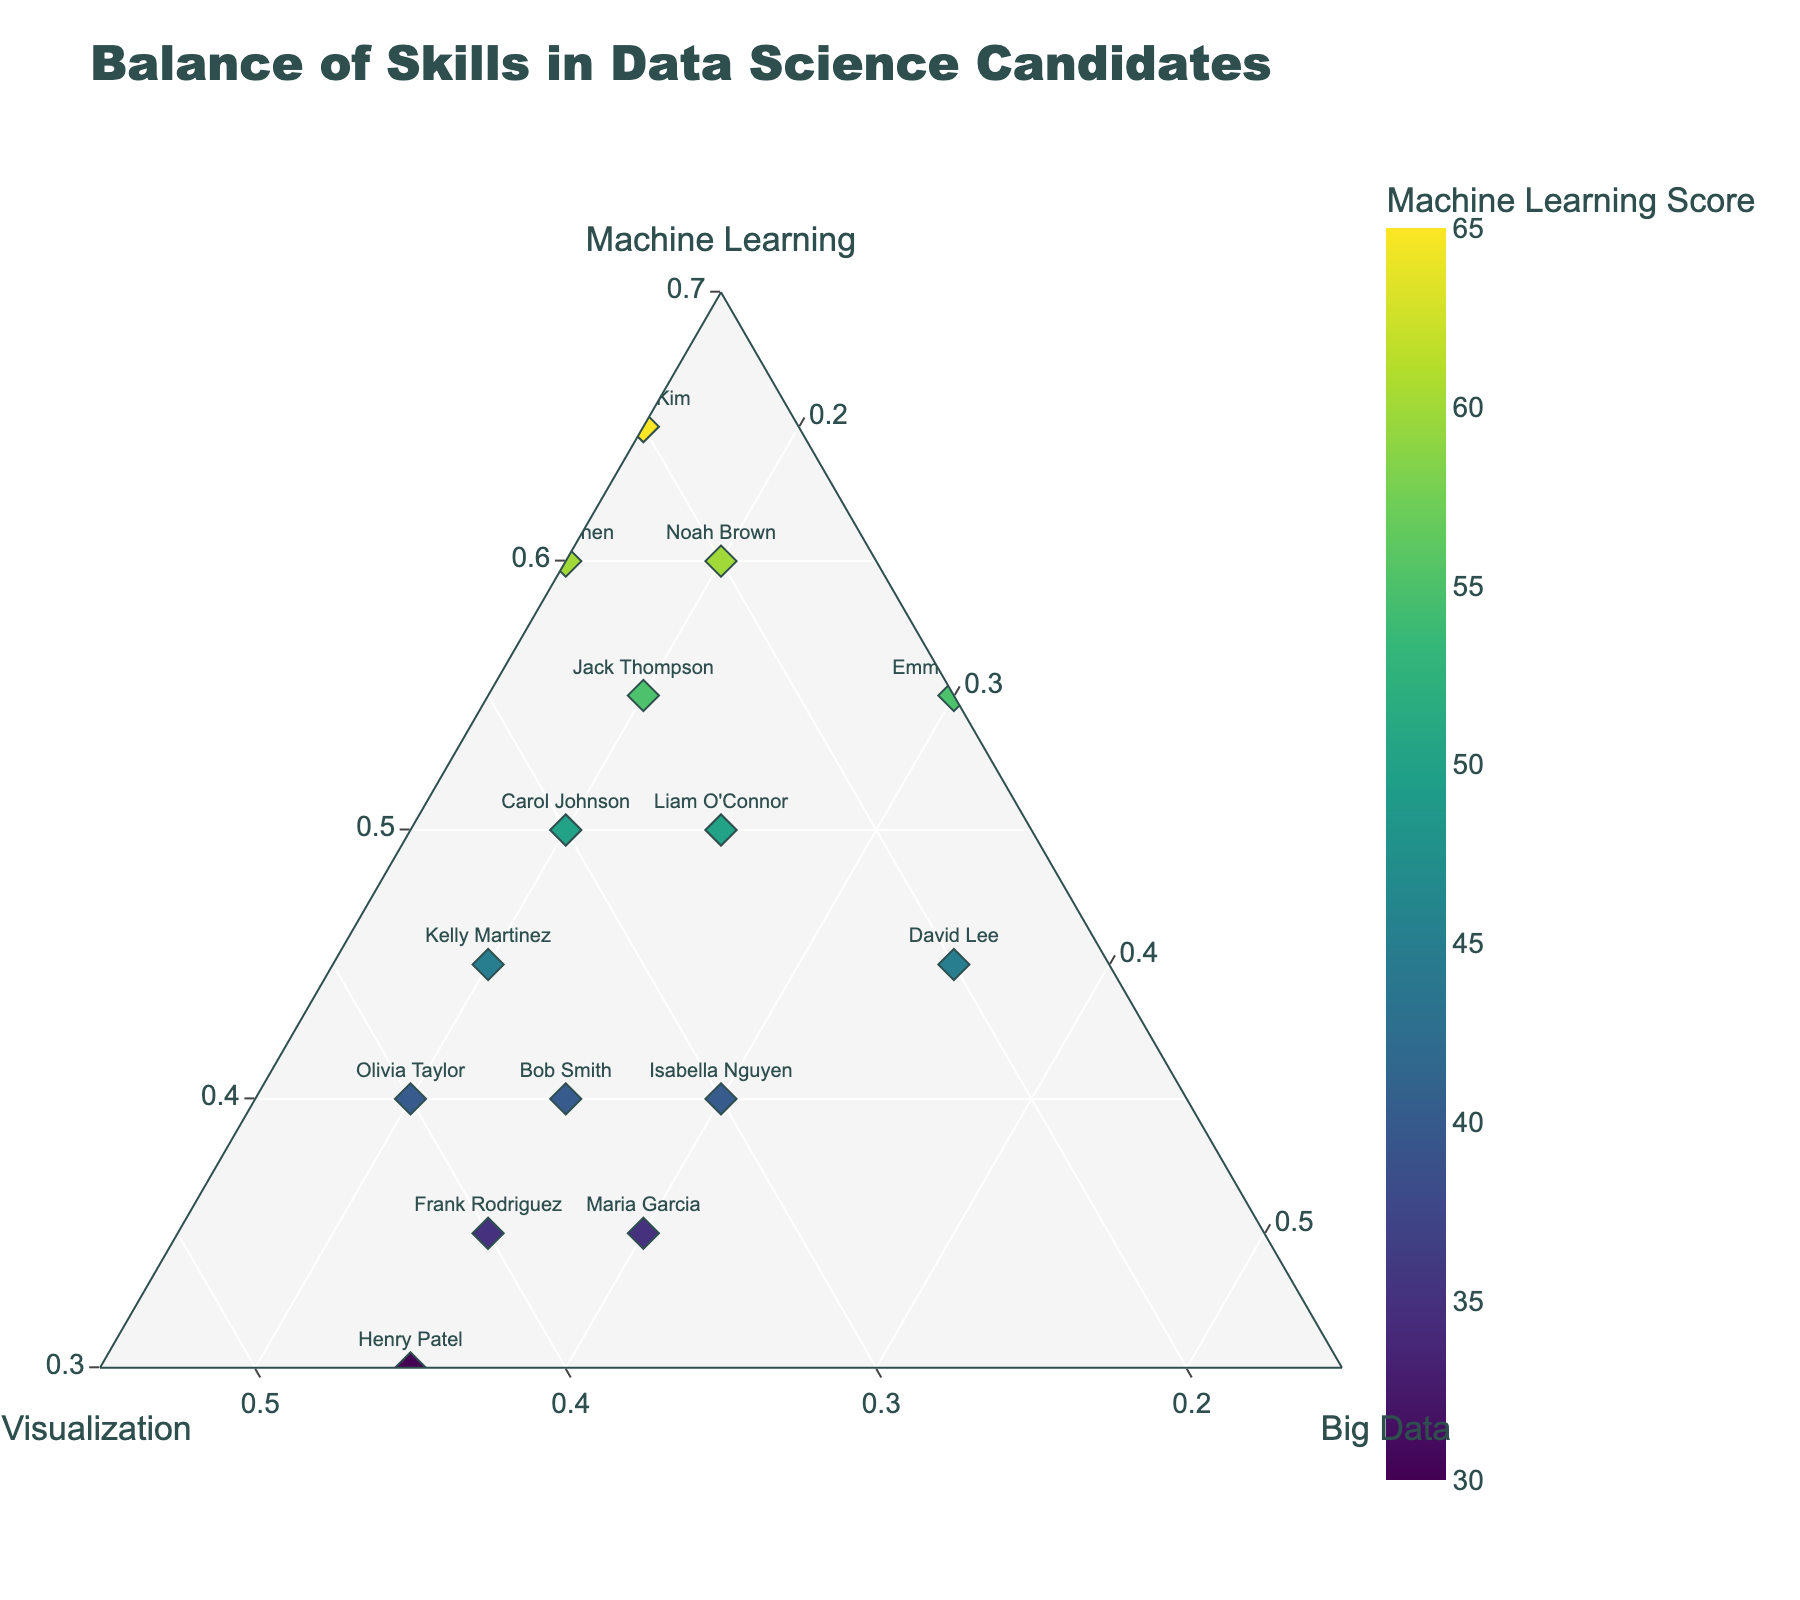How many candidates have a higher proportion of Machine Learning skills compared to the other two skills? By looking at the plot, candidates with a higher proportion of Machine Learning skills will be closer to the "Machine Learning" corner of the ternary plot. Count these candidates by inspecting their positions.
Answer: 6 Which candidate has the highest machine learning score? The highest machine learning score can be identified by finding the candidate with the largest value on the "Machine Learning" axis, indicated by the colorbar with the title "Machine Learning Score".
Answer: Grace Kim What is the average weight of Data Visualization skills among all candidates? Calculate the sum of the Data Visualization scores for all candidates and then divide by the number of candidates. Sum = 25 + 35 + 30 + 20 + 15 + 40 + 20 + 45 + 30 + 25 + 35 + 25 + 35 + 20 + 40 = 440. Number of candidates = 15. Average = 440 / 15 = ~29.33
Answer: 29.33 Which candidate has an equal proportion of Data Visualization and Big Data skills? Check the plot for candidates who are positioned equidistant from the “Data Visualization” and “Big Data” corners. This indicates equal proportions.
Answer: Isabella Nguyen Which two candidates have the most similar skill balance across all three categories? Look for candidates who are closest together on the plot, indicating similar proportions of all three skills. The smaller the distance between their positions, the more similar their skill balance.
Answer: Bob Smith and Kelly Martinez Which axis had the narrowest range of minimum values added by the candidates? By observing the minimum axis values in the layout configuration ('aaxis', 'baxis', 'caxis'), the minimum values for Machine Learning, Data Visualization, and Big Data are 0.3, 0.15, and 0.15 respectively. The narrowest minimum value is the axis for Data Visualization and Big Data.
Answer: Data Visualization and Big Data Is there any candidate who scored higher in Big Data than in both Machine Learning and Data Visualization? Inspect the ternary plot to see if any candidate is closest to the "Big Data" corner compared to the other two corners.
Answer: No Which candidate has the highest proportion of Big Data skills? The candidate closest to the "Big Data" corner of the ternary plot has the highest proportion of Big Data skills.
Answer: David Lee What is the most common skill balance trend among the candidates? Look at the clustering of points on the ternary plot to identify the general trend. Most points clustered closer to any one axis will indicate the trend.
Answer: Tendency towards Machine Learning with moderate Data Visualization and Big Data skills 